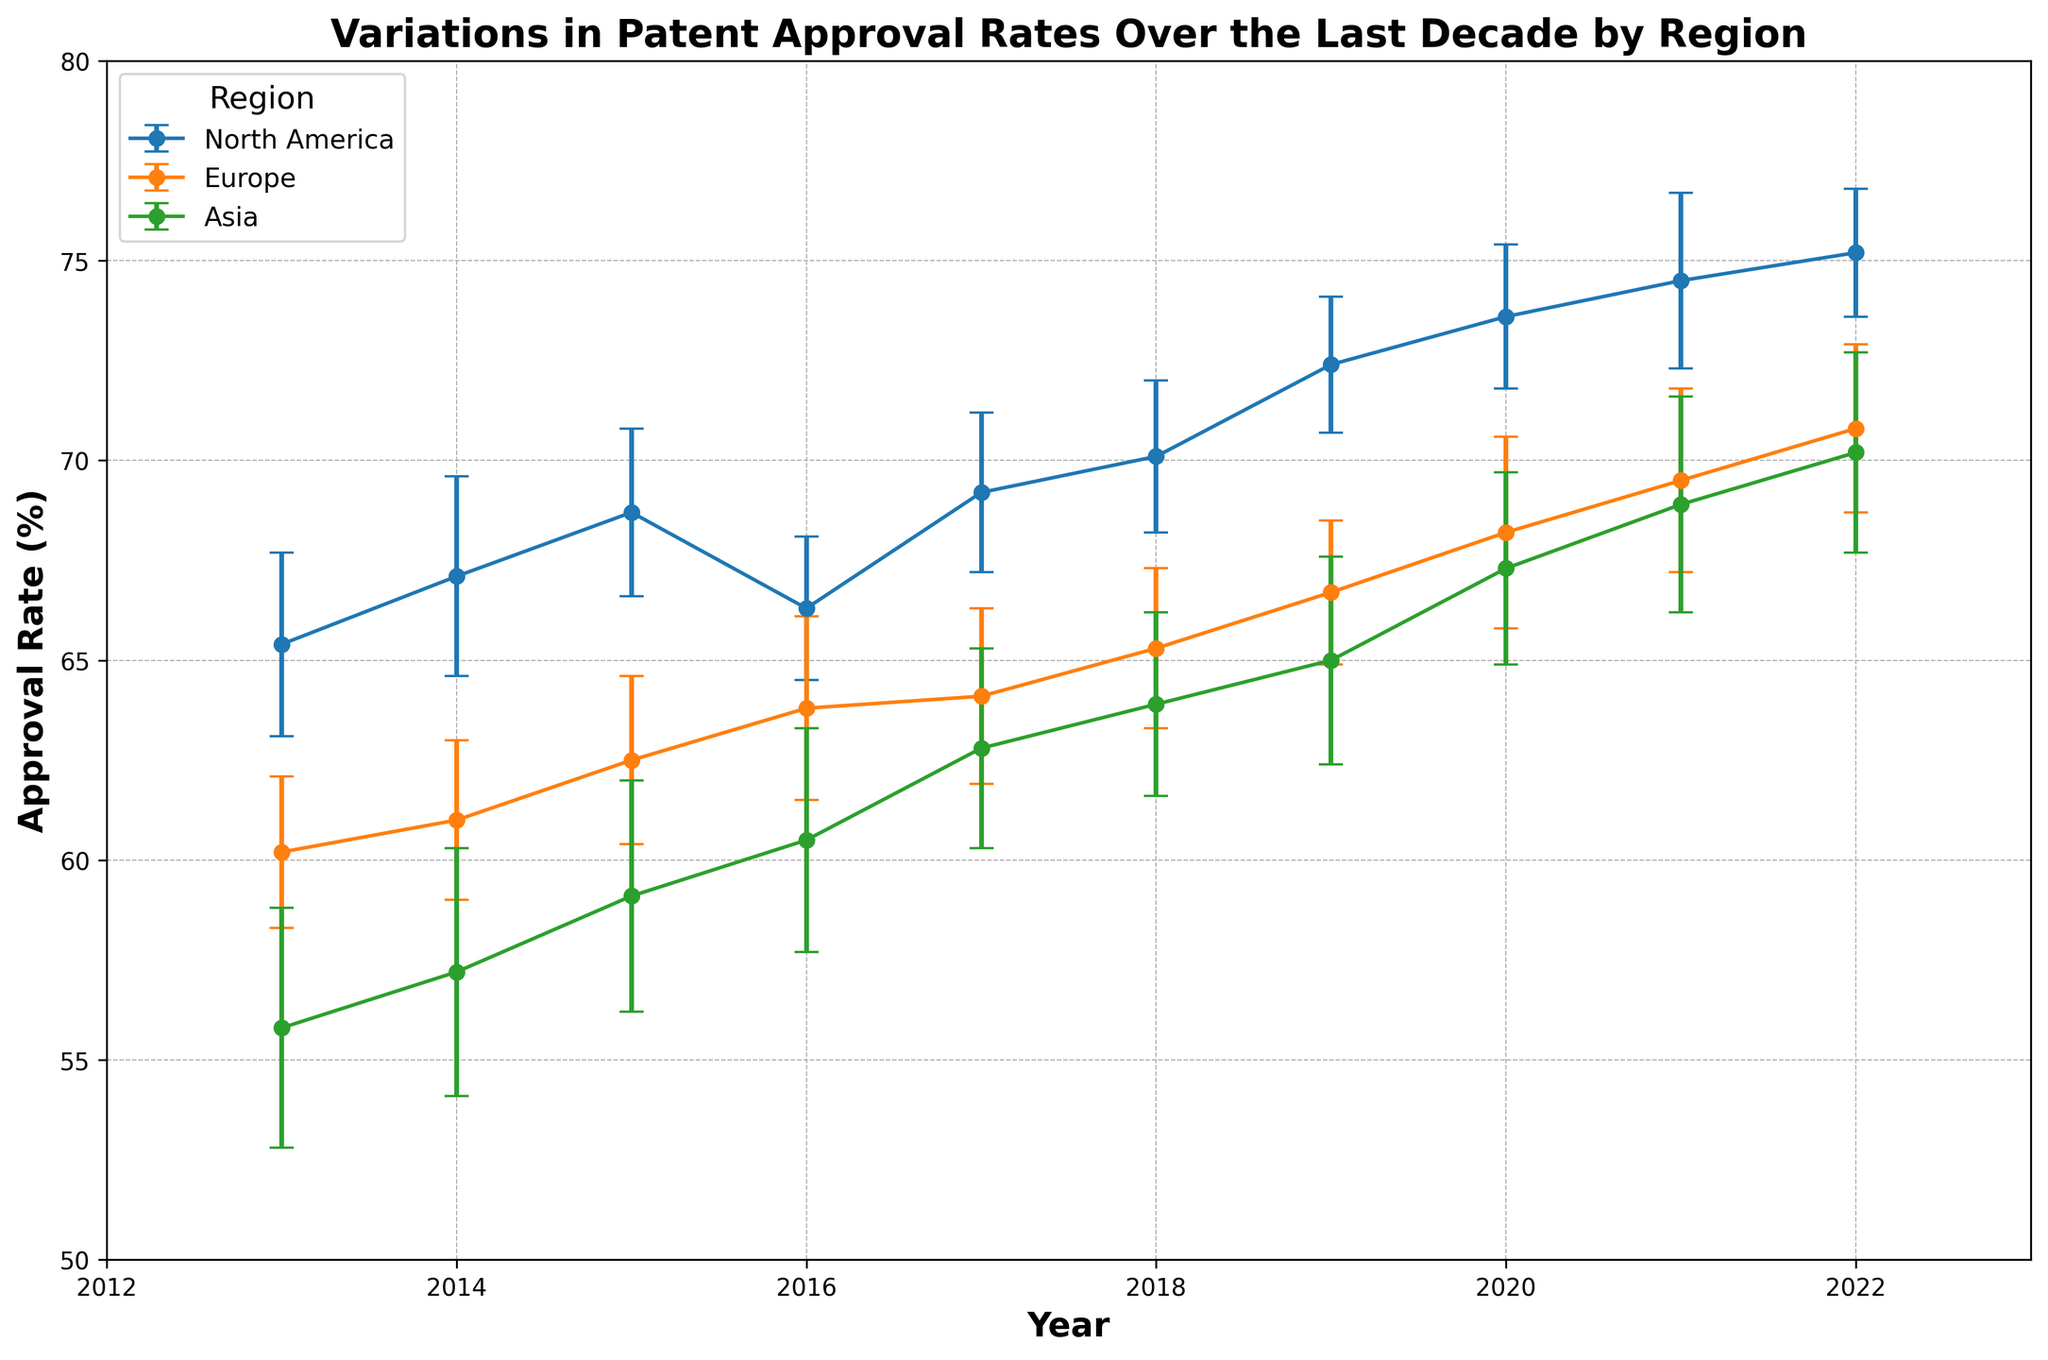What is the overall trend in patent approval rates in North America over the last decade? Over the decade, the approval rate in North America shows an increasing trend, starting from 65.4% in 2013 and reaching 75.2% in 2022. This can be seen by observing the upward movement of the data points year after year.
Answer: Increasing trend Which region had the highest approval rate in 2022? In 2022, North America had the highest approval rate. This is evident from the graph where North America's data point in 2022 is higher than those of Europe and Asia.
Answer: North America How does the approval rate in Asia in 2018 compare to that in Europe in 2018? In 2018, the approval rate in Asia was 63.9%, while in Europe, it was 65.3%. Comparing these values shows that Europe's approval rate was higher.
Answer: Europe was higher Which region shows the greatest increase in patent approval rate from 2013 to 2022? The increase in patent approval rate from 2013 to 2022 can be calculated for each region: 
- North America: 75.2% - 65.4% = 9.8%
- Europe: 70.8% - 60.2% = 10.6%
- Asia: 70.2% - 55.8% = 14.4%
From these calculations, Asia shows the greatest increase.
Answer: Asia What is the average patent approval rate in Europe over the decade? The average approval rate for Europe can be calculated by summing the approval rates for all the years and dividing by the number of years: 
(60.2 + 61.0 + 62.5 + 63.8 + 64.1 + 65.3 + 66.7 + 68.2 + 69.5 + 70.8) / 10 = 651.1 / 10 = 65.11%
Answer: 65.11% In which year did North America's approval rate experience a decline? By observing the years, North America's approval rate declined from 68.7% in 2015 to 66.3% in 2016. This is the only year where a drop is seen in the plotted data.
Answer: 2016 Compare the error bars for 2020 between North America and Europe. What can you infer about the variability of approval rates? In 2020, the error bar for North America is smaller compared to Europe, indicating that North America's approval rates have less variability and are more consistent during that year. Europe has larger error bars, indicating higher variability.
Answer: North America had less variability Which region had the least variability in approval rates in 2017 based on the length of the error bars? In 2017, North America has the smallest error bars among the regions, indicating that it had the least variability in approval rates for that year.
Answer: North America 